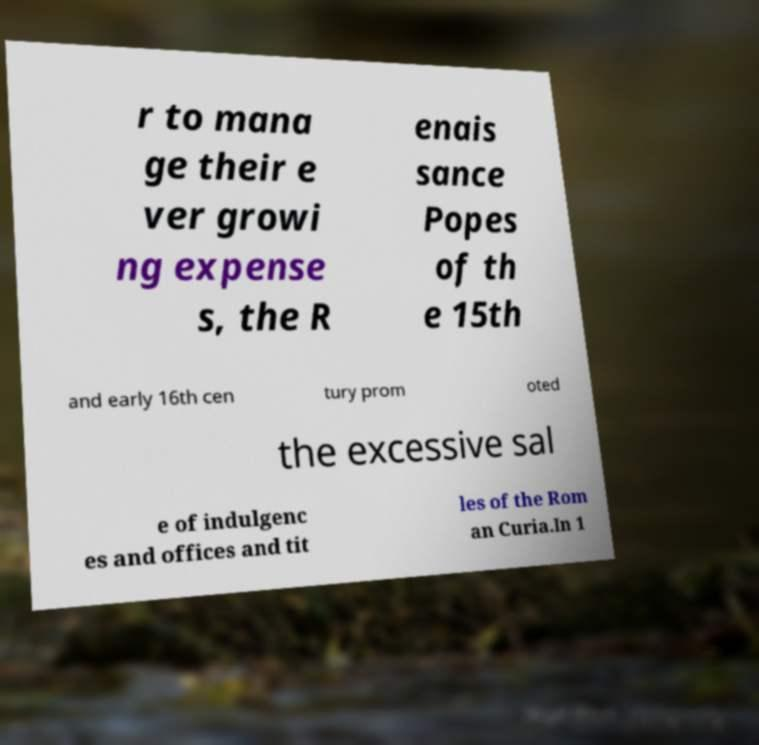Please read and relay the text visible in this image. What does it say? r to mana ge their e ver growi ng expense s, the R enais sance Popes of th e 15th and early 16th cen tury prom oted the excessive sal e of indulgenc es and offices and tit les of the Rom an Curia.In 1 